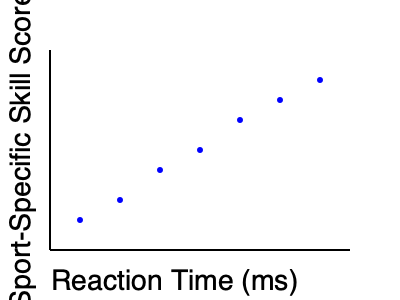Based on the scatter plot showing the relationship between reaction time and sport-specific skill scores, what type of correlation is observed, and how might this information be useful in sports psychology? To analyze the correlation between reaction time and sport-specific skill scores, we need to follow these steps:

1. Observe the overall pattern of the data points:
   The points form a downward sloping pattern from left to right.

2. Identify the type of correlation:
   As reaction time increases (x-axis), the sport-specific skill score decreases (y-axis).
   This indicates a negative or inverse correlation.

3. Assess the strength of the correlation:
   The points follow a fairly consistent pattern with little scatter.
   This suggests a strong negative correlation.

4. Interpret the relationship:
   Athletes with faster reaction times (lower values on x-axis) tend to have higher sport-specific skill scores.

5. Consider the implications for sports psychology:
   a) This data could be used to develop targeted training programs to improve reaction time.
   b) It might help in talent identification and player selection processes.
   c) Understanding this relationship could aid in designing more effective cognitive training exercises for athletes.
   d) It could inform research on the role of cognitive processes in sport performance.

6. Recognize limitations:
   Correlation does not imply causation. Other factors may influence both reaction time and skill scores.

In sports psychology, this information can be valuable for enhancing performance, developing training protocols, and understanding the cognitive aspects of athletic skills.
Answer: Strong negative correlation; useful for training design, talent identification, and understanding cognitive aspects of sport performance. 